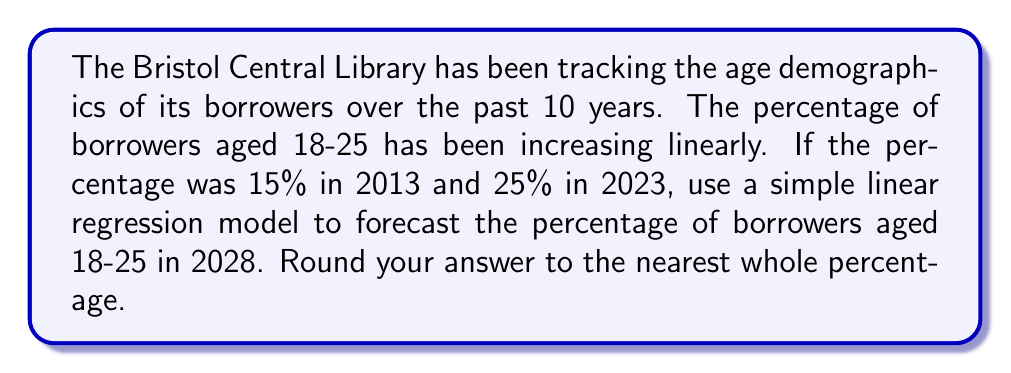Can you solve this math problem? To solve this problem, we'll use a simple linear regression model. The general form of a linear equation is:

$$y = mx + b$$

Where:
$y$ is the dependent variable (percentage of borrowers aged 18-25)
$x$ is the independent variable (years since 2013)
$m$ is the slope (rate of change per year)
$b$ is the y-intercept (initial percentage in 2013)

First, let's calculate the slope:

$$m = \frac{y_2 - y_1}{x_2 - x_1} = \frac{25\% - 15\%}{10 \text{ years}} = 1\% \text{ per year}$$

Now we know that $b = 15\%$ (the initial percentage in 2013) and $m = 1\%$ per year.

Our linear equation becomes:

$$y = 1x + 15$$

To forecast the percentage in 2028, we need to input $x = 15$ (15 years after 2013):

$$y = 1(15) + 15 = 30$$

Therefore, the forecasted percentage of borrowers aged 18-25 in 2028 is 30%.
Answer: 30% 